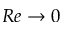Convert formula to latex. <formula><loc_0><loc_0><loc_500><loc_500>R e \to 0</formula> 